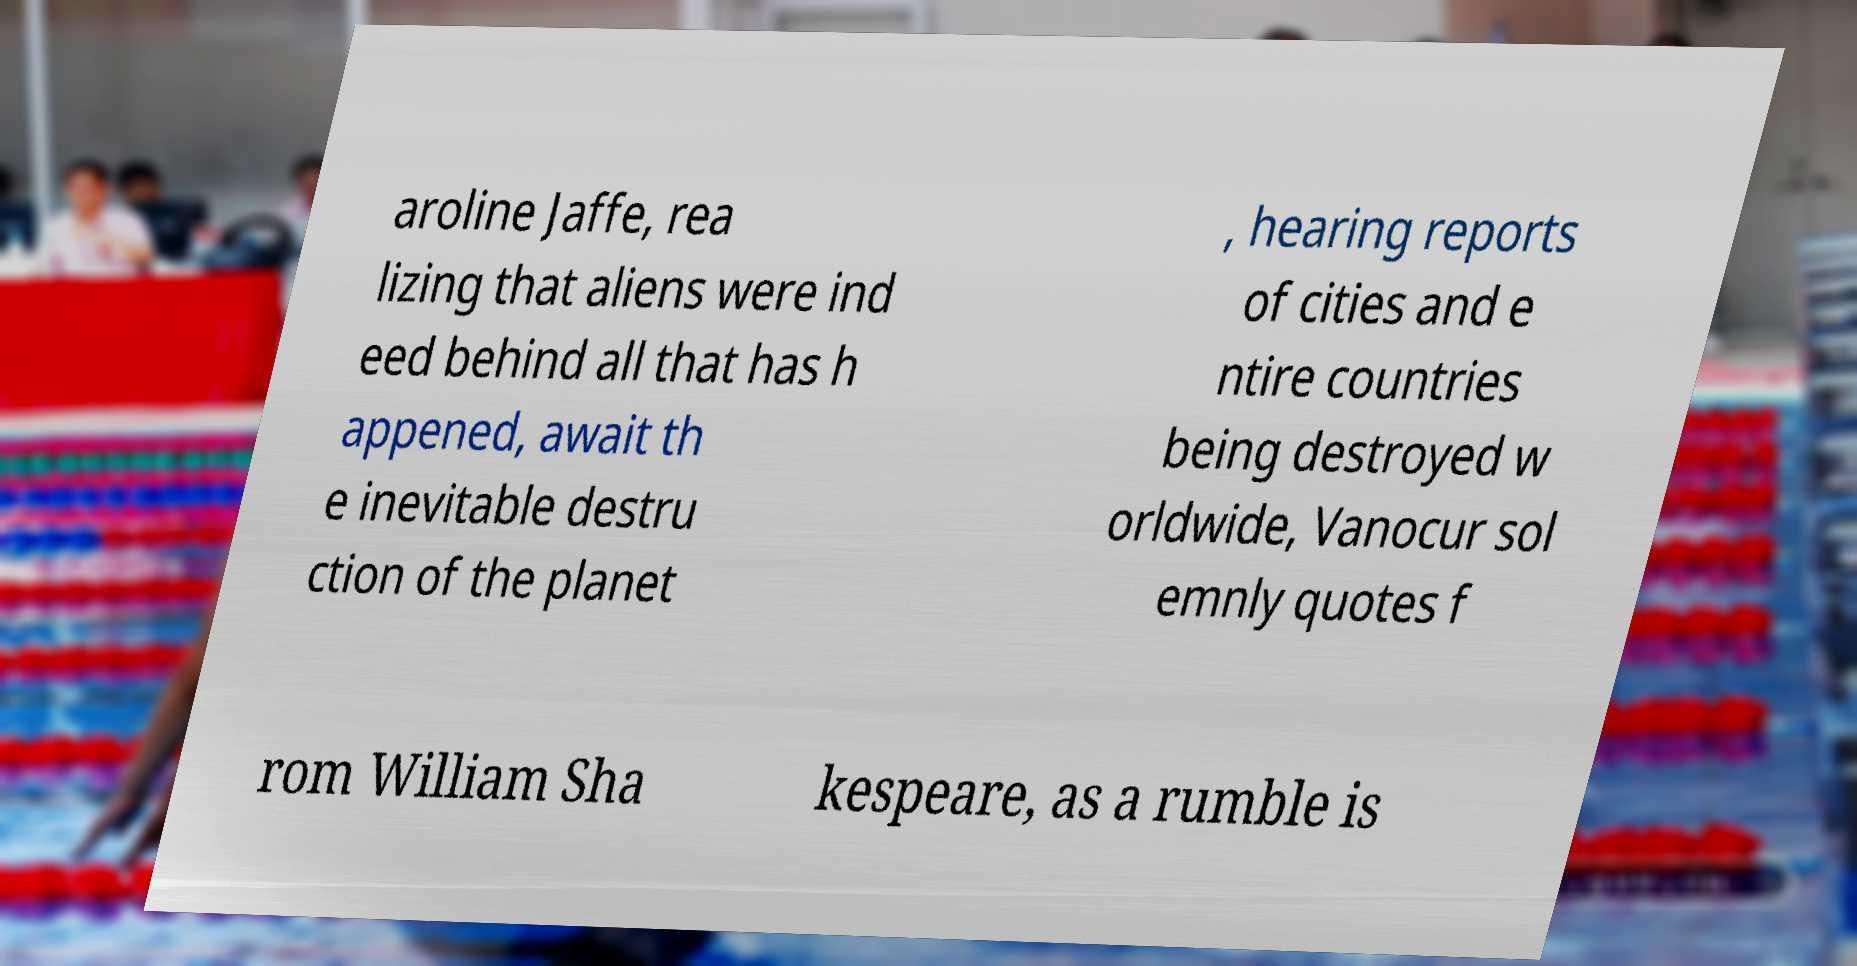There's text embedded in this image that I need extracted. Can you transcribe it verbatim? aroline Jaffe, rea lizing that aliens were ind eed behind all that has h appened, await th e inevitable destru ction of the planet , hearing reports of cities and e ntire countries being destroyed w orldwide, Vanocur sol emnly quotes f rom William Sha kespeare, as a rumble is 